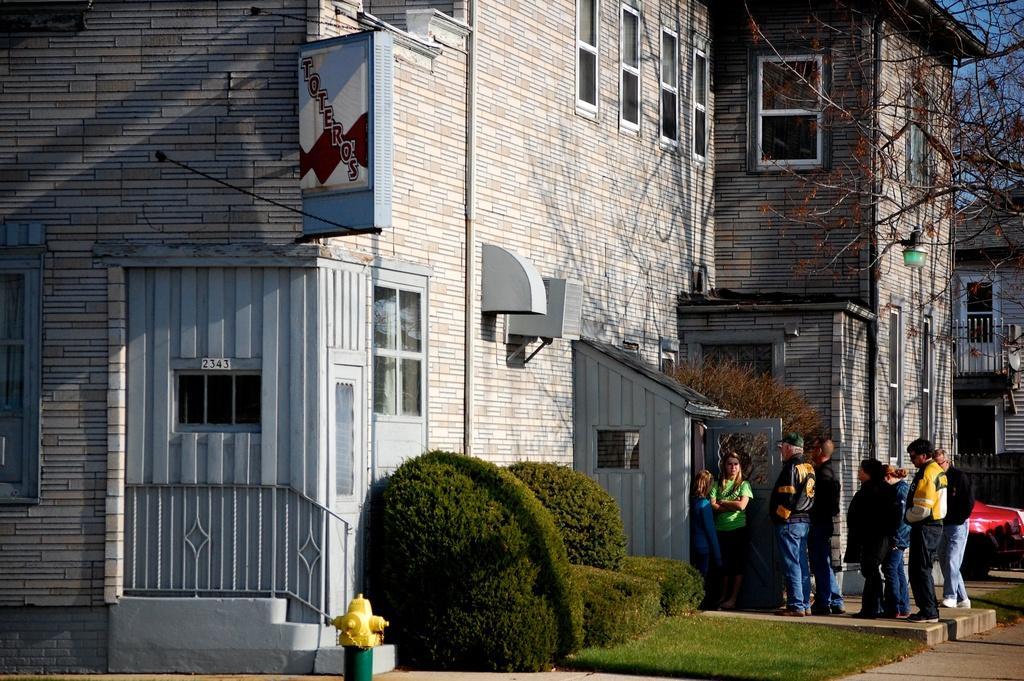Could you give a brief overview of what you see in this image? In the image I can see a place where we have some buildings and also I can see some plants and people to the side. 